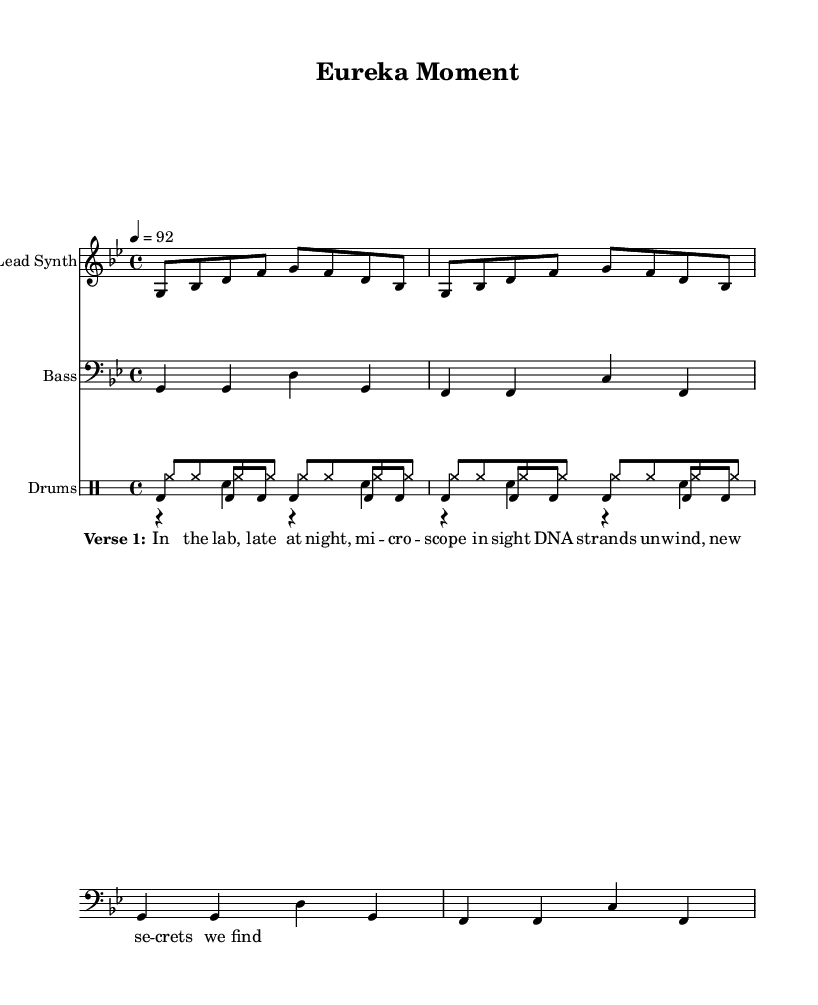What is the title of this piece? The title is indicated at the top of the sheet music under the header, which reads "Eureka Moment."
Answer: Eureka Moment What is the key signature of this music? The key signature is G minor, which is indicated by the presence of two flats (B flat and E flat).
Answer: G minor What is the time signature of this music? The time signature is displayed as 4/4, which signifies that there are four beats per measure and the quarter note gets one beat.
Answer: 4/4 What is the tempo marking given for this piece? The tempo is set at 92 beats per minute, indicated by the text "4 = 92," meaning there are 92 beats in one minute.
Answer: 92 How many measures are in the lead synth part? The lead synth part is composed of eight measures, as indicated by the repeated musical phrases designed to unfold twice.
Answer: Eight What type of musical genre does this piece represent? Given the structure and elements of the score, it represents the Rap genre, which is characterized by rhythmic vocal delivery and beats.
Answer: Rap Which instrument plays the bass line? The bass line is indicated on the staff labeled "Bass," which corresponds to the musical notation below the lead synth part.
Answer: Bass 